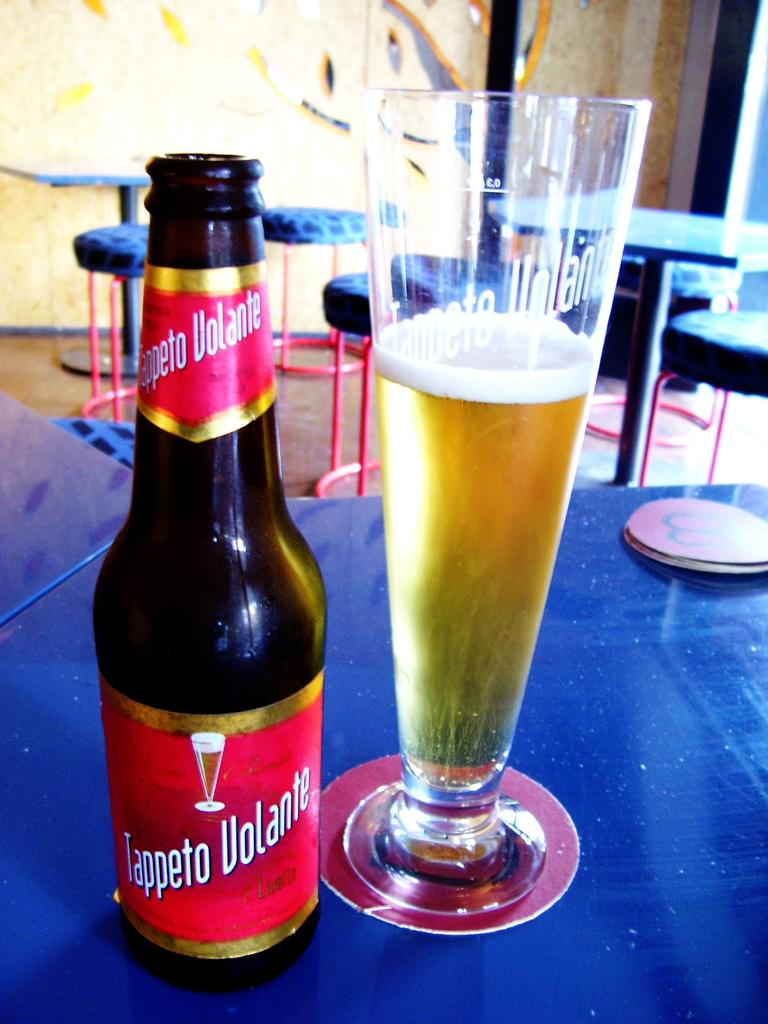<image>
Relay a brief, clear account of the picture shown. A bottle od Tappeto Volante sit next to a glass on a table with a blue table cloth. 